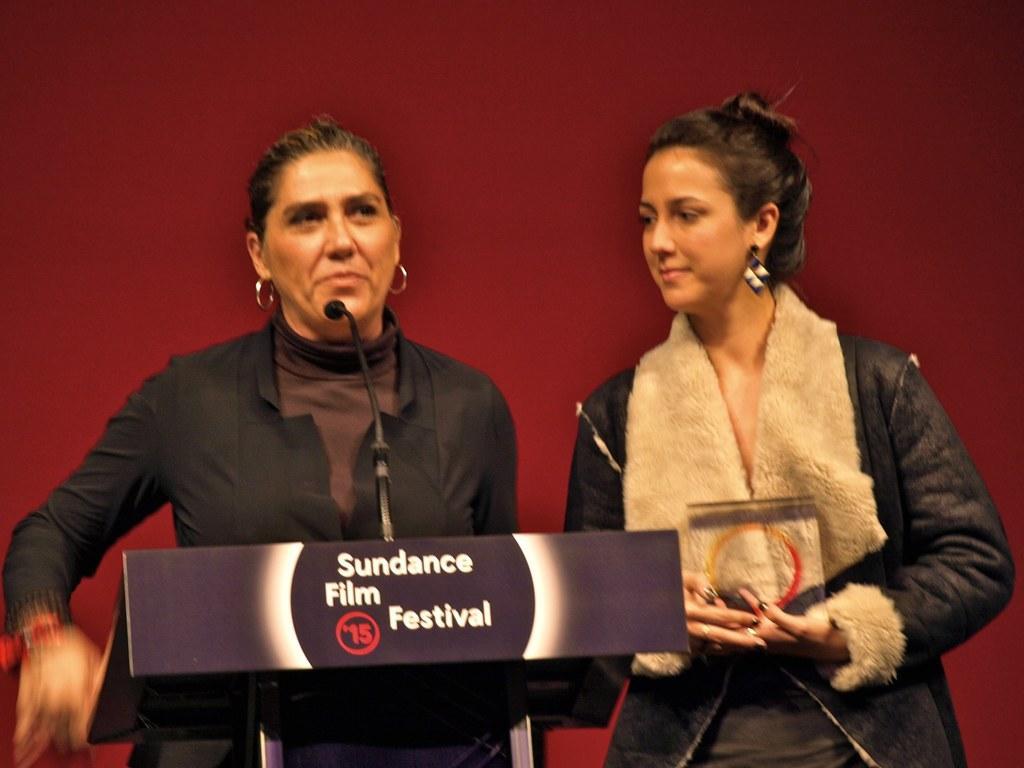Please provide a concise description of this image. On the right of this picture we can see a person wearing jacket, holding some object and seems to be standing. On the left we can see another person wearing black color dress and seems to be standing behind the podium and we can see the text and numbers on the podium and there is a microphone. In the background of the image we can see an object which seems to be the wall. 